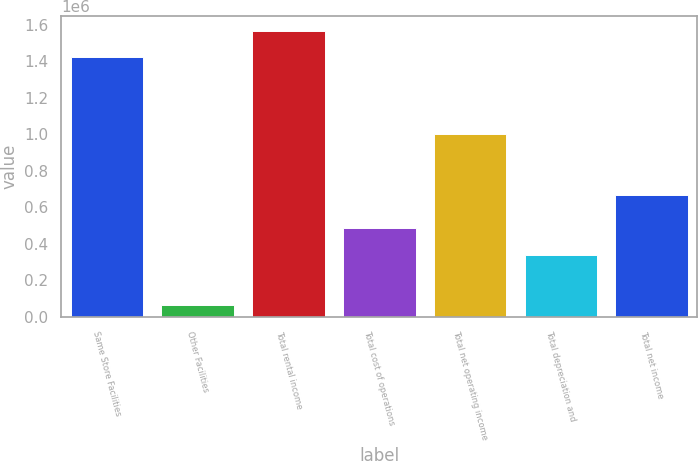<chart> <loc_0><loc_0><loc_500><loc_500><bar_chart><fcel>Same Store Facilities<fcel>Other Facilities<fcel>Total rental income<fcel>Total cost of operations<fcel>Total net operating income<fcel>Total depreciation and<fcel>Total net income<nl><fcel>1.42334e+06<fcel>63957<fcel>1.56567e+06<fcel>485695<fcel>1.0016e+06<fcel>336808<fcel>664792<nl></chart> 